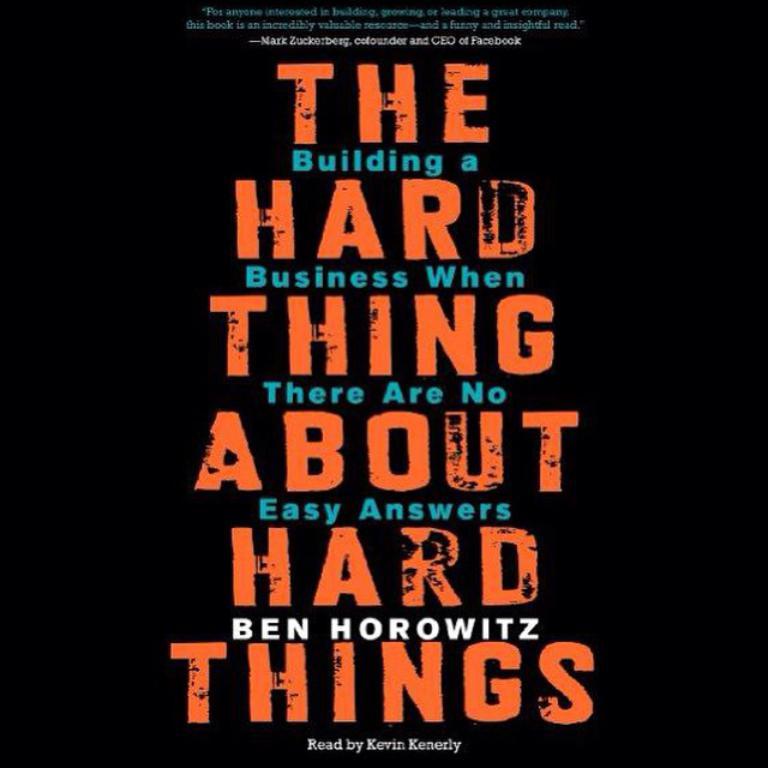Who wrote this book?
Your response must be concise. Ben horowitz. 